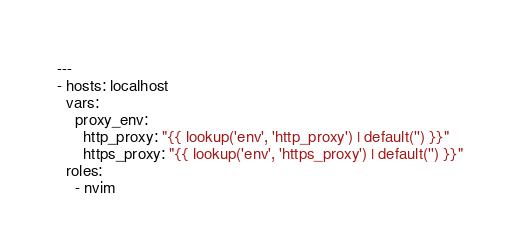<code> <loc_0><loc_0><loc_500><loc_500><_YAML_>---
- hosts: localhost
  vars:
    proxy_env:
      http_proxy: "{{ lookup('env', 'http_proxy') | default('') }}"
      https_proxy: "{{ lookup('env', 'https_proxy') | default('') }}"
  roles:
    - nvim
</code> 